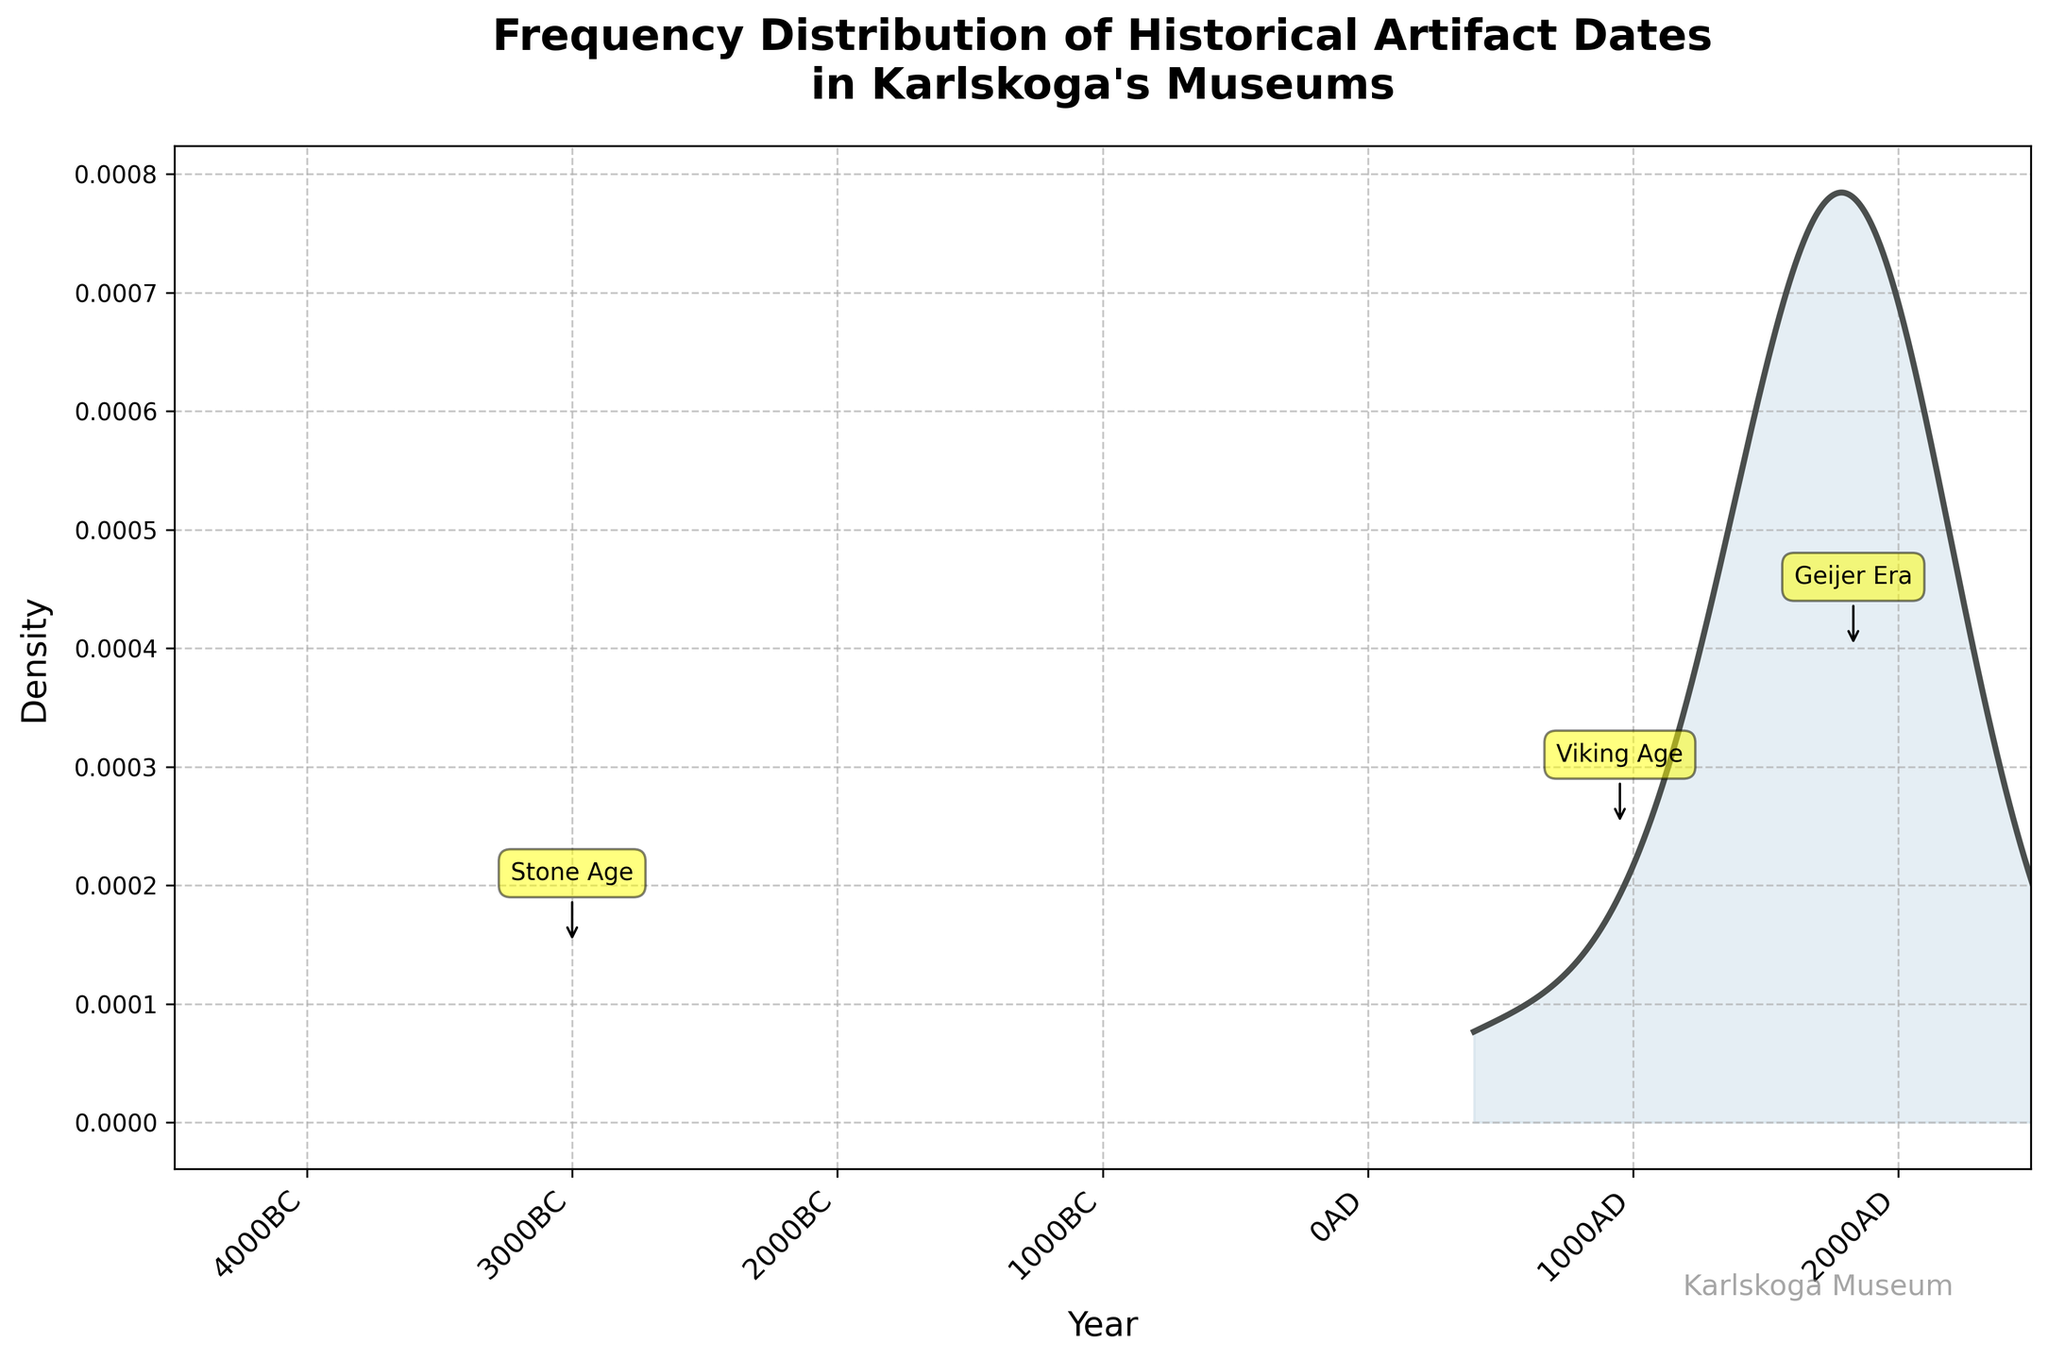What is the title of the plot? The title of the plot is typically located at the top of the figure. In this case, it reads: "Frequency Distribution of Historical Artifact Dates in Karlskoga's Museums".
Answer: Frequency Distribution of Historical Artifact Dates in Karlskoga's Museums What are the x-axis and y-axis labels? The labels for the axes describe what each axis represents. The x-axis is labeled "Year," and the y-axis is labeled "Density."
Answer: Year, Density During which periods does the plot show significant peaks? To determine this, you need to look for areas on the plot where the density line rises significantly. Major peaks can be seen around the Stone Age, the Viking Age, and the Geijer Era.
Answer: Stone Age, Viking Age, Geijer Era What is the range of years displayed on the x-axis? The x-axis shows the years ranging from the farthest left to the farthest right points. According to the plot, the x-axis ranges from -4000 (4000 BC) to 2500 (2500 AD).
Answer: 4000 BC to 2500 AD Are the annotations "Stone Age," "Viking Age," and "Geijer Era" properly aligned with peaks in the density plot? These annotations are visually positioned near peaks in the density graph, corresponding to significant increases in density during those periods.
Answer: Yes Which period shows the highest density according to the plot? By observing the maximal height of the density curve, the highest peak is observed around the Geijer Era, specifically near 1830 AD.
Answer: Geijer Era (around 1830 AD) What does the density value represent in this plot? The density value on the y-axis represents the estimated probability density of artifacts being from a particular year, indicating how frequently artifacts from that period appear in the data.
Answer: Estimated probability density of artifact dates How does the density during the Viking Age compare to the Geijer Era? To compare these periods, examine the heights of the density peaks: the Viking Age around 950 AD shows a lower density peak compared to the significantly higher peak around the Geijer Era at 1830 AD.
Answer: Geijer Era has a higher density than Viking Age Describe the pattern of artifact density from 1500 AD to 2500 AD. Observing the curve between these years, it starts with a relatively high density around 1830 AD (Geijer Era), slightly decreases, and then shows some minor fluctuations but remains relatively low, indicating a lesser frequency of artifacts from more recent periods.
Answer: High around 1830 AD, then decreases and remains low What do the gaps in the density plot indicate? Gaps in the density plot (regions where the density is very low or zero) suggest periods where few or no artifacts have been recorded, indicating potential historical periods with fewer artefacts discovered or preserved.
Answer: Periods with few or no recorded artifacts 